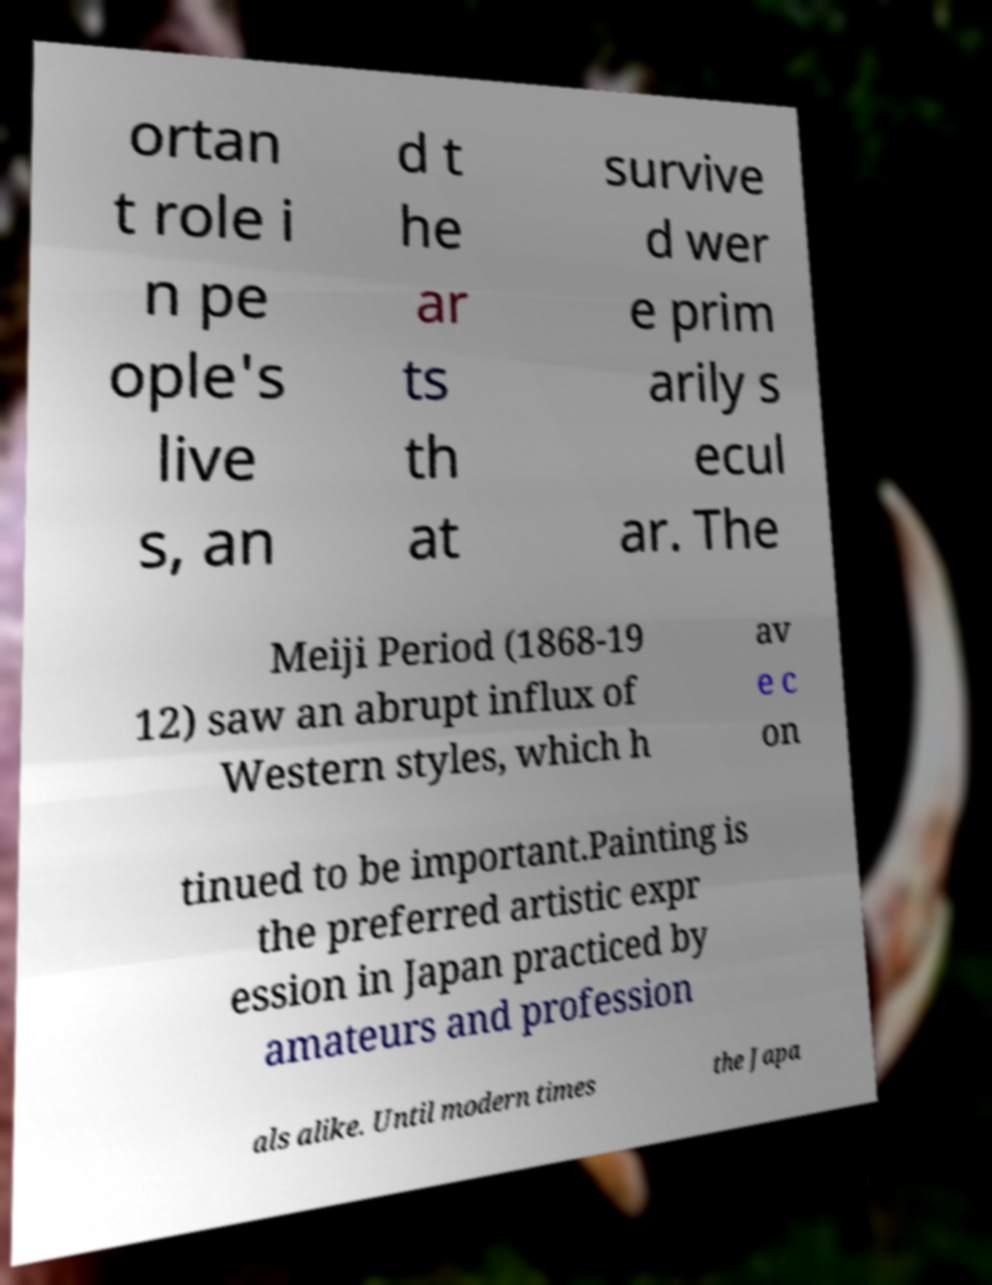Please identify and transcribe the text found in this image. ortan t role i n pe ople's live s, an d t he ar ts th at survive d wer e prim arily s ecul ar. The Meiji Period (1868-19 12) saw an abrupt influx of Western styles, which h av e c on tinued to be important.Painting is the preferred artistic expr ession in Japan practiced by amateurs and profession als alike. Until modern times the Japa 